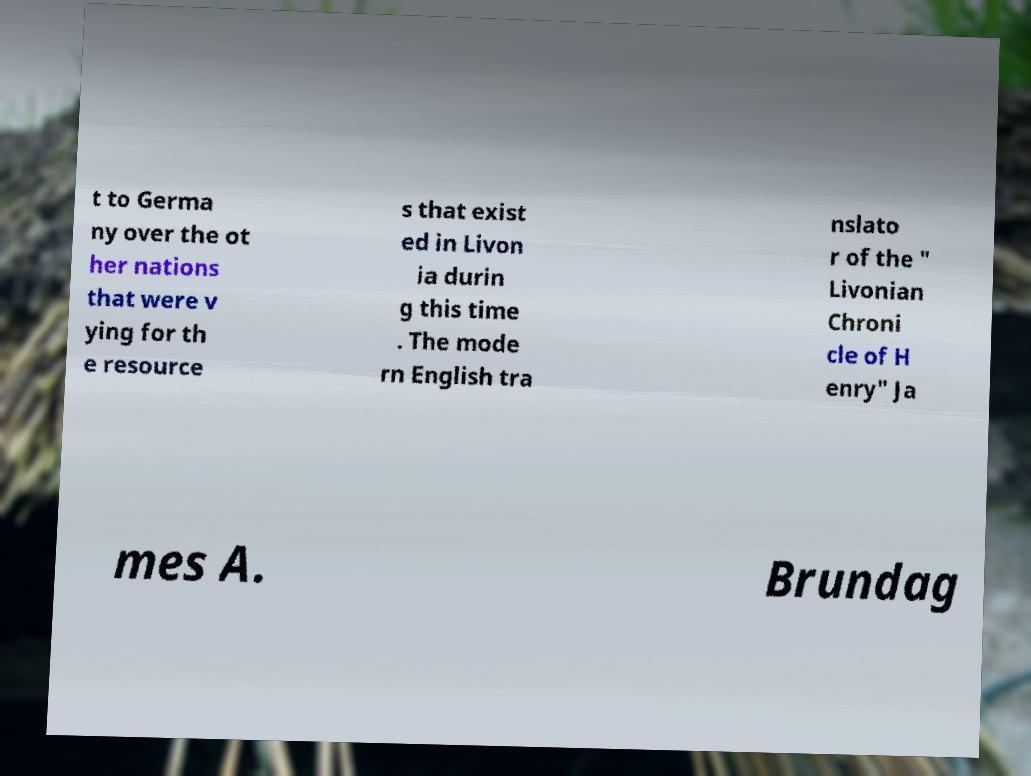Please identify and transcribe the text found in this image. t to Germa ny over the ot her nations that were v ying for th e resource s that exist ed in Livon ia durin g this time . The mode rn English tra nslato r of the " Livonian Chroni cle of H enry" Ja mes A. Brundag 